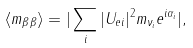<formula> <loc_0><loc_0><loc_500><loc_500>\langle m _ { \beta \beta } \rangle = | \sum _ { i } | U _ { e i } | ^ { 2 } m _ { \nu _ { i } } e ^ { i \alpha _ { i } } | ,</formula> 